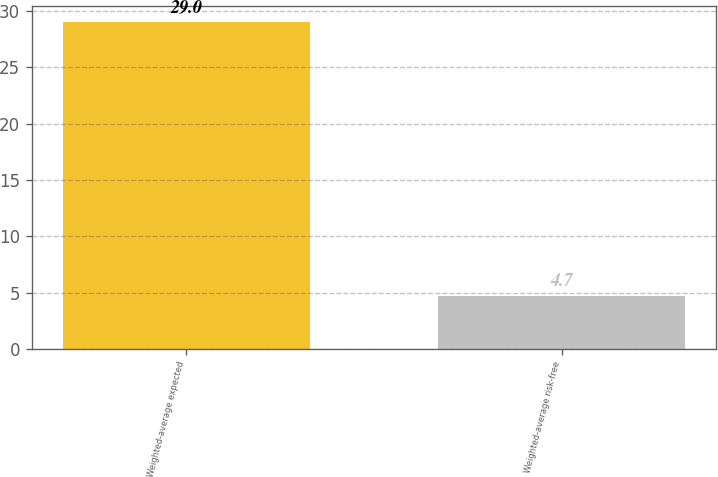<chart> <loc_0><loc_0><loc_500><loc_500><bar_chart><fcel>Weighted-average expected<fcel>Weighted-average risk-free<nl><fcel>29<fcel>4.7<nl></chart> 